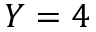<formula> <loc_0><loc_0><loc_500><loc_500>Y = 4</formula> 